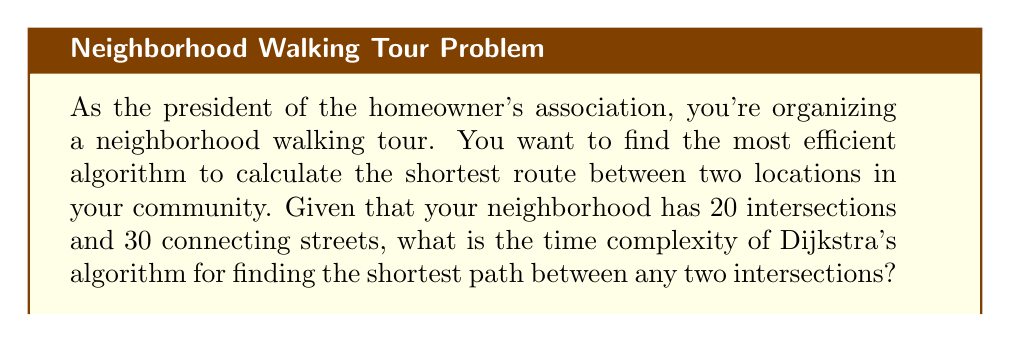Give your solution to this math problem. To analyze the time complexity of Dijkstra's algorithm for this scenario, we need to consider the following:

1. The neighborhood can be represented as a graph where:
   - Intersections are vertices (V)
   - Streets are edges (E)

2. In this case:
   - Number of vertices (V) = 20
   - Number of edges (E) = 30

3. Dijkstra's algorithm time complexity depends on the implementation:

   a. Using an adjacency matrix and linear search:
      Time complexity: $O(V^2)$

   b. Using a min-priority queue with binary heap:
      Time complexity: $O((V + E) \log V)$

   c. Using a Fibonacci heap:
      Time complexity: $O(E + V \log V)$

4. For this problem, we'll use the most common implementation with a binary heap:

   $O((V + E) \log V)$

5. Substituting the given values:

   $O((20 + 30) \log 20)$

6. Simplifying:

   $O(50 \log 20)$

The time complexity remains $O((V + E) \log V)$, but we can see how the specific values affect the actual running time.

This implementation of Dijkstra's algorithm is generally efficient for sparse graphs (where E is much smaller than $V^2$), which is often the case in real-world road networks.
Answer: The time complexity of Dijkstra's algorithm for finding the shortest path in the given neighborhood is $O((V + E) \log V)$, which simplifies to $O(50 \log 20)$ for the specific values provided. 